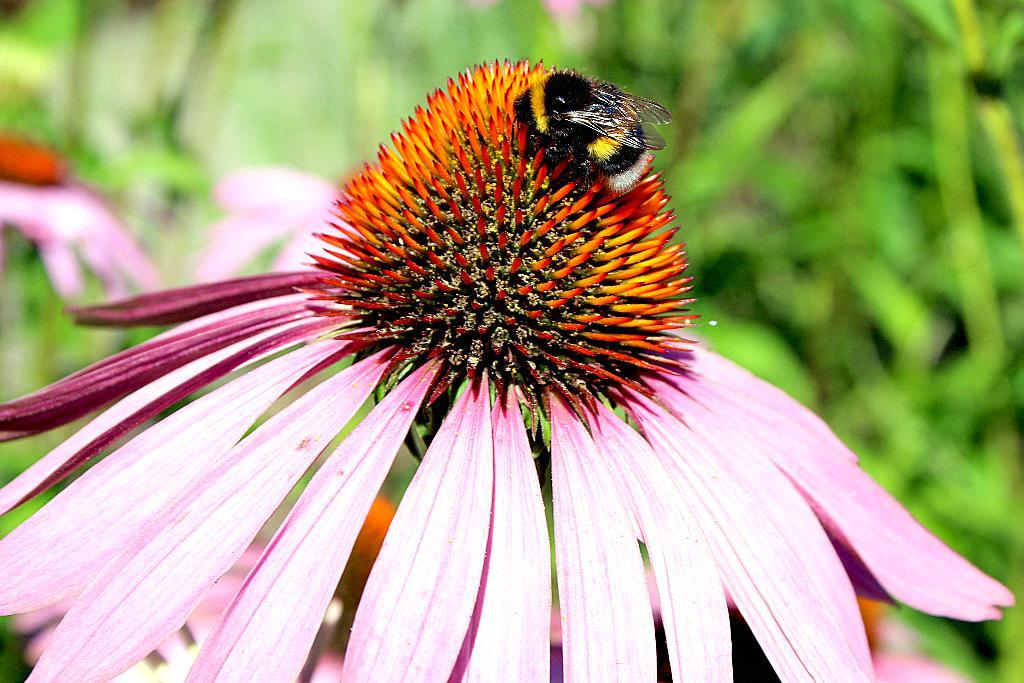What is the main subject of the image? There is a honey bee in the image. Where is the honey bee located in the image? The honey bee is sitting on a flower. Can you describe the background of the image? The background of the image is blurred. Can you tell me how many mothers are visible in the image? There are no mothers present in the image; it features a honey bee sitting on a flower. What type of hill can be seen in the background of the image? There is no hill visible in the image; the background is blurred. 